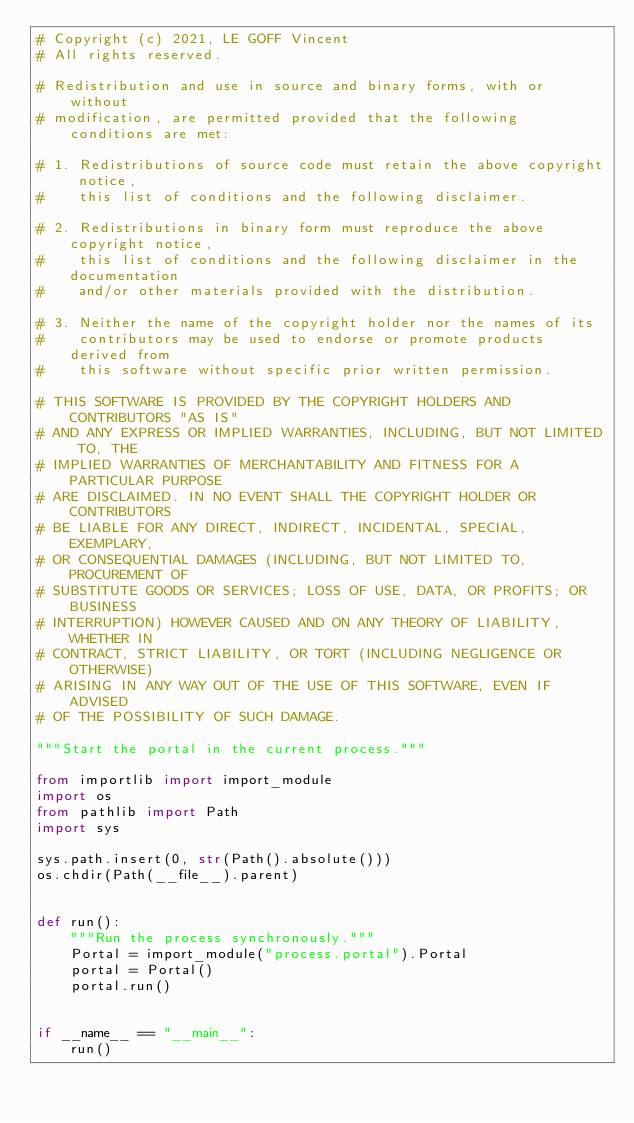Convert code to text. <code><loc_0><loc_0><loc_500><loc_500><_Python_># Copyright (c) 2021, LE GOFF Vincent
# All rights reserved.

# Redistribution and use in source and binary forms, with or without
# modification, are permitted provided that the following conditions are met:

# 1. Redistributions of source code must retain the above copyright notice,
#    this list of conditions and the following disclaimer.

# 2. Redistributions in binary form must reproduce the above copyright notice,
#    this list of conditions and the following disclaimer in the documentation
#    and/or other materials provided with the distribution.

# 3. Neither the name of the copyright holder nor the names of its
#    contributors may be used to endorse or promote products derived from
#    this software without specific prior written permission.

# THIS SOFTWARE IS PROVIDED BY THE COPYRIGHT HOLDERS AND CONTRIBUTORS "AS IS"
# AND ANY EXPRESS OR IMPLIED WARRANTIES, INCLUDING, BUT NOT LIMITED TO, THE
# IMPLIED WARRANTIES OF MERCHANTABILITY AND FITNESS FOR A PARTICULAR PURPOSE
# ARE DISCLAIMED. IN NO EVENT SHALL THE COPYRIGHT HOLDER OR CONTRIBUTORS
# BE LIABLE FOR ANY DIRECT, INDIRECT, INCIDENTAL, SPECIAL, EXEMPLARY,
# OR CONSEQUENTIAL DAMAGES (INCLUDING, BUT NOT LIMITED TO, PROCUREMENT OF
# SUBSTITUTE GOODS OR SERVICES; LOSS OF USE, DATA, OR PROFITS; OR BUSINESS
# INTERRUPTION) HOWEVER CAUSED AND ON ANY THEORY OF LIABILITY, WHETHER IN
# CONTRACT, STRICT LIABILITY, OR TORT (INCLUDING NEGLIGENCE OR OTHERWISE)
# ARISING IN ANY WAY OUT OF THE USE OF THIS SOFTWARE, EVEN IF ADVISED
# OF THE POSSIBILITY OF SUCH DAMAGE.

"""Start the portal in the current process."""

from importlib import import_module
import os
from pathlib import Path
import sys

sys.path.insert(0, str(Path().absolute()))
os.chdir(Path(__file__).parent)


def run():
    """Run the process synchronously."""
    Portal = import_module("process.portal").Portal
    portal = Portal()
    portal.run()


if __name__ == "__main__":
    run()
</code> 